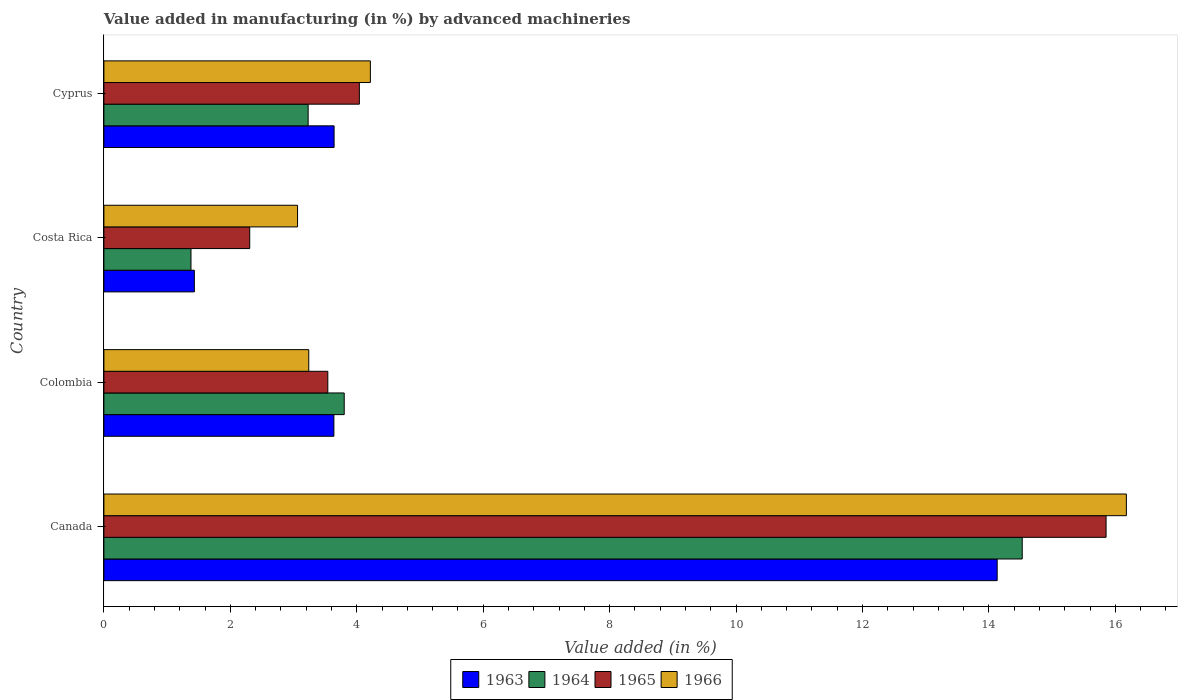How many groups of bars are there?
Offer a terse response. 4. How many bars are there on the 3rd tick from the top?
Keep it short and to the point. 4. What is the label of the 2nd group of bars from the top?
Your response must be concise. Costa Rica. In how many cases, is the number of bars for a given country not equal to the number of legend labels?
Your answer should be very brief. 0. What is the percentage of value added in manufacturing by advanced machineries in 1963 in Costa Rica?
Give a very brief answer. 1.43. Across all countries, what is the maximum percentage of value added in manufacturing by advanced machineries in 1966?
Provide a short and direct response. 16.17. Across all countries, what is the minimum percentage of value added in manufacturing by advanced machineries in 1963?
Give a very brief answer. 1.43. In which country was the percentage of value added in manufacturing by advanced machineries in 1965 maximum?
Your answer should be very brief. Canada. What is the total percentage of value added in manufacturing by advanced machineries in 1965 in the graph?
Provide a succinct answer. 25.74. What is the difference between the percentage of value added in manufacturing by advanced machineries in 1966 in Costa Rica and that in Cyprus?
Provide a short and direct response. -1.15. What is the difference between the percentage of value added in manufacturing by advanced machineries in 1965 in Colombia and the percentage of value added in manufacturing by advanced machineries in 1963 in Cyprus?
Your answer should be very brief. -0.1. What is the average percentage of value added in manufacturing by advanced machineries in 1965 per country?
Provide a short and direct response. 6.44. What is the difference between the percentage of value added in manufacturing by advanced machineries in 1963 and percentage of value added in manufacturing by advanced machineries in 1964 in Canada?
Make the answer very short. -0.4. What is the ratio of the percentage of value added in manufacturing by advanced machineries in 1963 in Costa Rica to that in Cyprus?
Offer a very short reply. 0.39. Is the difference between the percentage of value added in manufacturing by advanced machineries in 1963 in Canada and Costa Rica greater than the difference between the percentage of value added in manufacturing by advanced machineries in 1964 in Canada and Costa Rica?
Give a very brief answer. No. What is the difference between the highest and the second highest percentage of value added in manufacturing by advanced machineries in 1966?
Offer a very short reply. 11.96. What is the difference between the highest and the lowest percentage of value added in manufacturing by advanced machineries in 1965?
Provide a succinct answer. 13.55. In how many countries, is the percentage of value added in manufacturing by advanced machineries in 1966 greater than the average percentage of value added in manufacturing by advanced machineries in 1966 taken over all countries?
Offer a terse response. 1. Is the sum of the percentage of value added in manufacturing by advanced machineries in 1966 in Canada and Cyprus greater than the maximum percentage of value added in manufacturing by advanced machineries in 1963 across all countries?
Offer a terse response. Yes. Is it the case that in every country, the sum of the percentage of value added in manufacturing by advanced machineries in 1965 and percentage of value added in manufacturing by advanced machineries in 1966 is greater than the sum of percentage of value added in manufacturing by advanced machineries in 1964 and percentage of value added in manufacturing by advanced machineries in 1963?
Keep it short and to the point. No. What does the 2nd bar from the top in Costa Rica represents?
Keep it short and to the point. 1965. What does the 3rd bar from the bottom in Canada represents?
Your answer should be compact. 1965. How many bars are there?
Keep it short and to the point. 16. How many countries are there in the graph?
Offer a terse response. 4. Does the graph contain any zero values?
Make the answer very short. No. Where does the legend appear in the graph?
Make the answer very short. Bottom center. How are the legend labels stacked?
Your answer should be very brief. Horizontal. What is the title of the graph?
Offer a terse response. Value added in manufacturing (in %) by advanced machineries. Does "2009" appear as one of the legend labels in the graph?
Offer a terse response. No. What is the label or title of the X-axis?
Keep it short and to the point. Value added (in %). What is the label or title of the Y-axis?
Make the answer very short. Country. What is the Value added (in %) in 1963 in Canada?
Offer a very short reply. 14.13. What is the Value added (in %) in 1964 in Canada?
Offer a terse response. 14.53. What is the Value added (in %) of 1965 in Canada?
Give a very brief answer. 15.85. What is the Value added (in %) in 1966 in Canada?
Your response must be concise. 16.17. What is the Value added (in %) in 1963 in Colombia?
Offer a terse response. 3.64. What is the Value added (in %) of 1964 in Colombia?
Make the answer very short. 3.8. What is the Value added (in %) in 1965 in Colombia?
Offer a very short reply. 3.54. What is the Value added (in %) of 1966 in Colombia?
Offer a terse response. 3.24. What is the Value added (in %) in 1963 in Costa Rica?
Provide a short and direct response. 1.43. What is the Value added (in %) in 1964 in Costa Rica?
Your response must be concise. 1.38. What is the Value added (in %) in 1965 in Costa Rica?
Keep it short and to the point. 2.31. What is the Value added (in %) in 1966 in Costa Rica?
Offer a terse response. 3.06. What is the Value added (in %) in 1963 in Cyprus?
Offer a terse response. 3.64. What is the Value added (in %) in 1964 in Cyprus?
Your answer should be very brief. 3.23. What is the Value added (in %) of 1965 in Cyprus?
Ensure brevity in your answer.  4.04. What is the Value added (in %) in 1966 in Cyprus?
Offer a very short reply. 4.22. Across all countries, what is the maximum Value added (in %) in 1963?
Your response must be concise. 14.13. Across all countries, what is the maximum Value added (in %) of 1964?
Make the answer very short. 14.53. Across all countries, what is the maximum Value added (in %) of 1965?
Offer a very short reply. 15.85. Across all countries, what is the maximum Value added (in %) of 1966?
Make the answer very short. 16.17. Across all countries, what is the minimum Value added (in %) in 1963?
Your answer should be very brief. 1.43. Across all countries, what is the minimum Value added (in %) in 1964?
Ensure brevity in your answer.  1.38. Across all countries, what is the minimum Value added (in %) in 1965?
Give a very brief answer. 2.31. Across all countries, what is the minimum Value added (in %) of 1966?
Ensure brevity in your answer.  3.06. What is the total Value added (in %) of 1963 in the graph?
Give a very brief answer. 22.84. What is the total Value added (in %) of 1964 in the graph?
Your answer should be compact. 22.94. What is the total Value added (in %) in 1965 in the graph?
Your answer should be very brief. 25.74. What is the total Value added (in %) of 1966 in the graph?
Offer a very short reply. 26.69. What is the difference between the Value added (in %) in 1963 in Canada and that in Colombia?
Make the answer very short. 10.49. What is the difference between the Value added (in %) in 1964 in Canada and that in Colombia?
Provide a short and direct response. 10.72. What is the difference between the Value added (in %) in 1965 in Canada and that in Colombia?
Ensure brevity in your answer.  12.31. What is the difference between the Value added (in %) in 1966 in Canada and that in Colombia?
Provide a succinct answer. 12.93. What is the difference between the Value added (in %) of 1963 in Canada and that in Costa Rica?
Offer a very short reply. 12.7. What is the difference between the Value added (in %) of 1964 in Canada and that in Costa Rica?
Provide a succinct answer. 13.15. What is the difference between the Value added (in %) of 1965 in Canada and that in Costa Rica?
Your answer should be very brief. 13.55. What is the difference between the Value added (in %) of 1966 in Canada and that in Costa Rica?
Your response must be concise. 13.11. What is the difference between the Value added (in %) in 1963 in Canada and that in Cyprus?
Your response must be concise. 10.49. What is the difference between the Value added (in %) in 1964 in Canada and that in Cyprus?
Your answer should be very brief. 11.3. What is the difference between the Value added (in %) of 1965 in Canada and that in Cyprus?
Keep it short and to the point. 11.81. What is the difference between the Value added (in %) in 1966 in Canada and that in Cyprus?
Provide a short and direct response. 11.96. What is the difference between the Value added (in %) of 1963 in Colombia and that in Costa Rica?
Provide a succinct answer. 2.21. What is the difference between the Value added (in %) in 1964 in Colombia and that in Costa Rica?
Ensure brevity in your answer.  2.42. What is the difference between the Value added (in %) of 1965 in Colombia and that in Costa Rica?
Give a very brief answer. 1.24. What is the difference between the Value added (in %) of 1966 in Colombia and that in Costa Rica?
Your response must be concise. 0.18. What is the difference between the Value added (in %) of 1963 in Colombia and that in Cyprus?
Keep it short and to the point. -0. What is the difference between the Value added (in %) in 1964 in Colombia and that in Cyprus?
Make the answer very short. 0.57. What is the difference between the Value added (in %) of 1965 in Colombia and that in Cyprus?
Provide a short and direct response. -0.5. What is the difference between the Value added (in %) of 1966 in Colombia and that in Cyprus?
Offer a very short reply. -0.97. What is the difference between the Value added (in %) of 1963 in Costa Rica and that in Cyprus?
Your answer should be very brief. -2.21. What is the difference between the Value added (in %) of 1964 in Costa Rica and that in Cyprus?
Give a very brief answer. -1.85. What is the difference between the Value added (in %) of 1965 in Costa Rica and that in Cyprus?
Provide a short and direct response. -1.73. What is the difference between the Value added (in %) of 1966 in Costa Rica and that in Cyprus?
Give a very brief answer. -1.15. What is the difference between the Value added (in %) of 1963 in Canada and the Value added (in %) of 1964 in Colombia?
Offer a very short reply. 10.33. What is the difference between the Value added (in %) of 1963 in Canada and the Value added (in %) of 1965 in Colombia?
Your answer should be very brief. 10.59. What is the difference between the Value added (in %) of 1963 in Canada and the Value added (in %) of 1966 in Colombia?
Your answer should be compact. 10.89. What is the difference between the Value added (in %) in 1964 in Canada and the Value added (in %) in 1965 in Colombia?
Offer a very short reply. 10.98. What is the difference between the Value added (in %) of 1964 in Canada and the Value added (in %) of 1966 in Colombia?
Give a very brief answer. 11.29. What is the difference between the Value added (in %) of 1965 in Canada and the Value added (in %) of 1966 in Colombia?
Your answer should be very brief. 12.61. What is the difference between the Value added (in %) of 1963 in Canada and the Value added (in %) of 1964 in Costa Rica?
Keep it short and to the point. 12.75. What is the difference between the Value added (in %) of 1963 in Canada and the Value added (in %) of 1965 in Costa Rica?
Give a very brief answer. 11.82. What is the difference between the Value added (in %) in 1963 in Canada and the Value added (in %) in 1966 in Costa Rica?
Your answer should be very brief. 11.07. What is the difference between the Value added (in %) of 1964 in Canada and the Value added (in %) of 1965 in Costa Rica?
Offer a terse response. 12.22. What is the difference between the Value added (in %) of 1964 in Canada and the Value added (in %) of 1966 in Costa Rica?
Your answer should be compact. 11.46. What is the difference between the Value added (in %) in 1965 in Canada and the Value added (in %) in 1966 in Costa Rica?
Your answer should be very brief. 12.79. What is the difference between the Value added (in %) of 1963 in Canada and the Value added (in %) of 1964 in Cyprus?
Your response must be concise. 10.9. What is the difference between the Value added (in %) of 1963 in Canada and the Value added (in %) of 1965 in Cyprus?
Give a very brief answer. 10.09. What is the difference between the Value added (in %) in 1963 in Canada and the Value added (in %) in 1966 in Cyprus?
Your answer should be very brief. 9.92. What is the difference between the Value added (in %) in 1964 in Canada and the Value added (in %) in 1965 in Cyprus?
Your answer should be compact. 10.49. What is the difference between the Value added (in %) in 1964 in Canada and the Value added (in %) in 1966 in Cyprus?
Give a very brief answer. 10.31. What is the difference between the Value added (in %) of 1965 in Canada and the Value added (in %) of 1966 in Cyprus?
Give a very brief answer. 11.64. What is the difference between the Value added (in %) of 1963 in Colombia and the Value added (in %) of 1964 in Costa Rica?
Offer a terse response. 2.26. What is the difference between the Value added (in %) in 1963 in Colombia and the Value added (in %) in 1965 in Costa Rica?
Provide a short and direct response. 1.33. What is the difference between the Value added (in %) in 1963 in Colombia and the Value added (in %) in 1966 in Costa Rica?
Provide a succinct answer. 0.57. What is the difference between the Value added (in %) of 1964 in Colombia and the Value added (in %) of 1965 in Costa Rica?
Your answer should be compact. 1.49. What is the difference between the Value added (in %) of 1964 in Colombia and the Value added (in %) of 1966 in Costa Rica?
Provide a short and direct response. 0.74. What is the difference between the Value added (in %) in 1965 in Colombia and the Value added (in %) in 1966 in Costa Rica?
Your response must be concise. 0.48. What is the difference between the Value added (in %) of 1963 in Colombia and the Value added (in %) of 1964 in Cyprus?
Offer a terse response. 0.41. What is the difference between the Value added (in %) in 1963 in Colombia and the Value added (in %) in 1965 in Cyprus?
Give a very brief answer. -0.4. What is the difference between the Value added (in %) of 1963 in Colombia and the Value added (in %) of 1966 in Cyprus?
Give a very brief answer. -0.58. What is the difference between the Value added (in %) of 1964 in Colombia and the Value added (in %) of 1965 in Cyprus?
Make the answer very short. -0.24. What is the difference between the Value added (in %) in 1964 in Colombia and the Value added (in %) in 1966 in Cyprus?
Offer a very short reply. -0.41. What is the difference between the Value added (in %) of 1965 in Colombia and the Value added (in %) of 1966 in Cyprus?
Offer a terse response. -0.67. What is the difference between the Value added (in %) in 1963 in Costa Rica and the Value added (in %) in 1964 in Cyprus?
Your answer should be very brief. -1.8. What is the difference between the Value added (in %) in 1963 in Costa Rica and the Value added (in %) in 1965 in Cyprus?
Ensure brevity in your answer.  -2.61. What is the difference between the Value added (in %) of 1963 in Costa Rica and the Value added (in %) of 1966 in Cyprus?
Your answer should be compact. -2.78. What is the difference between the Value added (in %) of 1964 in Costa Rica and the Value added (in %) of 1965 in Cyprus?
Provide a short and direct response. -2.66. What is the difference between the Value added (in %) in 1964 in Costa Rica and the Value added (in %) in 1966 in Cyprus?
Your answer should be very brief. -2.84. What is the difference between the Value added (in %) in 1965 in Costa Rica and the Value added (in %) in 1966 in Cyprus?
Give a very brief answer. -1.91. What is the average Value added (in %) of 1963 per country?
Your answer should be compact. 5.71. What is the average Value added (in %) of 1964 per country?
Ensure brevity in your answer.  5.73. What is the average Value added (in %) of 1965 per country?
Give a very brief answer. 6.44. What is the average Value added (in %) in 1966 per country?
Offer a very short reply. 6.67. What is the difference between the Value added (in %) of 1963 and Value added (in %) of 1964 in Canada?
Provide a short and direct response. -0.4. What is the difference between the Value added (in %) of 1963 and Value added (in %) of 1965 in Canada?
Provide a short and direct response. -1.72. What is the difference between the Value added (in %) in 1963 and Value added (in %) in 1966 in Canada?
Your answer should be very brief. -2.04. What is the difference between the Value added (in %) in 1964 and Value added (in %) in 1965 in Canada?
Provide a succinct answer. -1.33. What is the difference between the Value added (in %) in 1964 and Value added (in %) in 1966 in Canada?
Ensure brevity in your answer.  -1.65. What is the difference between the Value added (in %) of 1965 and Value added (in %) of 1966 in Canada?
Ensure brevity in your answer.  -0.32. What is the difference between the Value added (in %) of 1963 and Value added (in %) of 1964 in Colombia?
Offer a terse response. -0.16. What is the difference between the Value added (in %) in 1963 and Value added (in %) in 1965 in Colombia?
Keep it short and to the point. 0.1. What is the difference between the Value added (in %) in 1963 and Value added (in %) in 1966 in Colombia?
Offer a very short reply. 0.4. What is the difference between the Value added (in %) in 1964 and Value added (in %) in 1965 in Colombia?
Your answer should be very brief. 0.26. What is the difference between the Value added (in %) of 1964 and Value added (in %) of 1966 in Colombia?
Provide a succinct answer. 0.56. What is the difference between the Value added (in %) in 1965 and Value added (in %) in 1966 in Colombia?
Your answer should be compact. 0.3. What is the difference between the Value added (in %) of 1963 and Value added (in %) of 1964 in Costa Rica?
Ensure brevity in your answer.  0.05. What is the difference between the Value added (in %) of 1963 and Value added (in %) of 1965 in Costa Rica?
Your answer should be compact. -0.88. What is the difference between the Value added (in %) of 1963 and Value added (in %) of 1966 in Costa Rica?
Offer a terse response. -1.63. What is the difference between the Value added (in %) of 1964 and Value added (in %) of 1965 in Costa Rica?
Provide a succinct answer. -0.93. What is the difference between the Value added (in %) in 1964 and Value added (in %) in 1966 in Costa Rica?
Offer a very short reply. -1.69. What is the difference between the Value added (in %) of 1965 and Value added (in %) of 1966 in Costa Rica?
Your response must be concise. -0.76. What is the difference between the Value added (in %) in 1963 and Value added (in %) in 1964 in Cyprus?
Your response must be concise. 0.41. What is the difference between the Value added (in %) in 1963 and Value added (in %) in 1965 in Cyprus?
Your response must be concise. -0.4. What is the difference between the Value added (in %) in 1963 and Value added (in %) in 1966 in Cyprus?
Keep it short and to the point. -0.57. What is the difference between the Value added (in %) of 1964 and Value added (in %) of 1965 in Cyprus?
Keep it short and to the point. -0.81. What is the difference between the Value added (in %) of 1964 and Value added (in %) of 1966 in Cyprus?
Your response must be concise. -0.98. What is the difference between the Value added (in %) in 1965 and Value added (in %) in 1966 in Cyprus?
Provide a short and direct response. -0.17. What is the ratio of the Value added (in %) in 1963 in Canada to that in Colombia?
Ensure brevity in your answer.  3.88. What is the ratio of the Value added (in %) of 1964 in Canada to that in Colombia?
Give a very brief answer. 3.82. What is the ratio of the Value added (in %) of 1965 in Canada to that in Colombia?
Provide a short and direct response. 4.48. What is the ratio of the Value added (in %) in 1966 in Canada to that in Colombia?
Your answer should be very brief. 4.99. What is the ratio of the Value added (in %) of 1963 in Canada to that in Costa Rica?
Ensure brevity in your answer.  9.87. What is the ratio of the Value added (in %) in 1964 in Canada to that in Costa Rica?
Make the answer very short. 10.54. What is the ratio of the Value added (in %) in 1965 in Canada to that in Costa Rica?
Your answer should be very brief. 6.87. What is the ratio of the Value added (in %) of 1966 in Canada to that in Costa Rica?
Your response must be concise. 5.28. What is the ratio of the Value added (in %) of 1963 in Canada to that in Cyprus?
Offer a very short reply. 3.88. What is the ratio of the Value added (in %) in 1964 in Canada to that in Cyprus?
Ensure brevity in your answer.  4.5. What is the ratio of the Value added (in %) in 1965 in Canada to that in Cyprus?
Ensure brevity in your answer.  3.92. What is the ratio of the Value added (in %) in 1966 in Canada to that in Cyprus?
Keep it short and to the point. 3.84. What is the ratio of the Value added (in %) in 1963 in Colombia to that in Costa Rica?
Your response must be concise. 2.54. What is the ratio of the Value added (in %) in 1964 in Colombia to that in Costa Rica?
Make the answer very short. 2.76. What is the ratio of the Value added (in %) in 1965 in Colombia to that in Costa Rica?
Keep it short and to the point. 1.54. What is the ratio of the Value added (in %) in 1966 in Colombia to that in Costa Rica?
Ensure brevity in your answer.  1.06. What is the ratio of the Value added (in %) of 1964 in Colombia to that in Cyprus?
Your response must be concise. 1.18. What is the ratio of the Value added (in %) of 1965 in Colombia to that in Cyprus?
Provide a short and direct response. 0.88. What is the ratio of the Value added (in %) of 1966 in Colombia to that in Cyprus?
Provide a succinct answer. 0.77. What is the ratio of the Value added (in %) in 1963 in Costa Rica to that in Cyprus?
Provide a succinct answer. 0.39. What is the ratio of the Value added (in %) in 1964 in Costa Rica to that in Cyprus?
Ensure brevity in your answer.  0.43. What is the ratio of the Value added (in %) in 1965 in Costa Rica to that in Cyprus?
Give a very brief answer. 0.57. What is the ratio of the Value added (in %) in 1966 in Costa Rica to that in Cyprus?
Provide a short and direct response. 0.73. What is the difference between the highest and the second highest Value added (in %) in 1963?
Ensure brevity in your answer.  10.49. What is the difference between the highest and the second highest Value added (in %) in 1964?
Your response must be concise. 10.72. What is the difference between the highest and the second highest Value added (in %) in 1965?
Your response must be concise. 11.81. What is the difference between the highest and the second highest Value added (in %) in 1966?
Provide a succinct answer. 11.96. What is the difference between the highest and the lowest Value added (in %) of 1963?
Ensure brevity in your answer.  12.7. What is the difference between the highest and the lowest Value added (in %) in 1964?
Offer a very short reply. 13.15. What is the difference between the highest and the lowest Value added (in %) of 1965?
Give a very brief answer. 13.55. What is the difference between the highest and the lowest Value added (in %) of 1966?
Your answer should be compact. 13.11. 